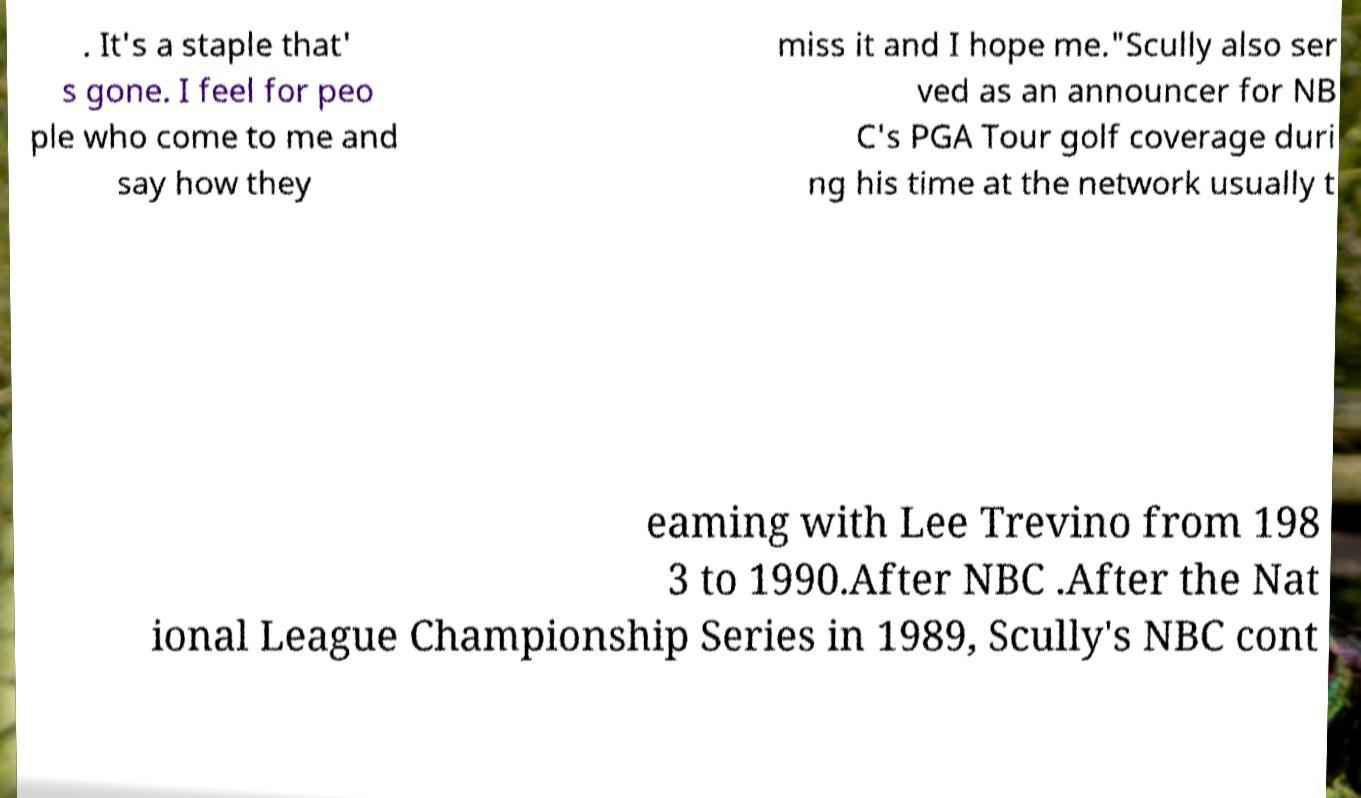Please identify and transcribe the text found in this image. . It's a staple that' s gone. I feel for peo ple who come to me and say how they miss it and I hope me."Scully also ser ved as an announcer for NB C's PGA Tour golf coverage duri ng his time at the network usually t eaming with Lee Trevino from 198 3 to 1990.After NBC .After the Nat ional League Championship Series in 1989, Scully's NBC cont 